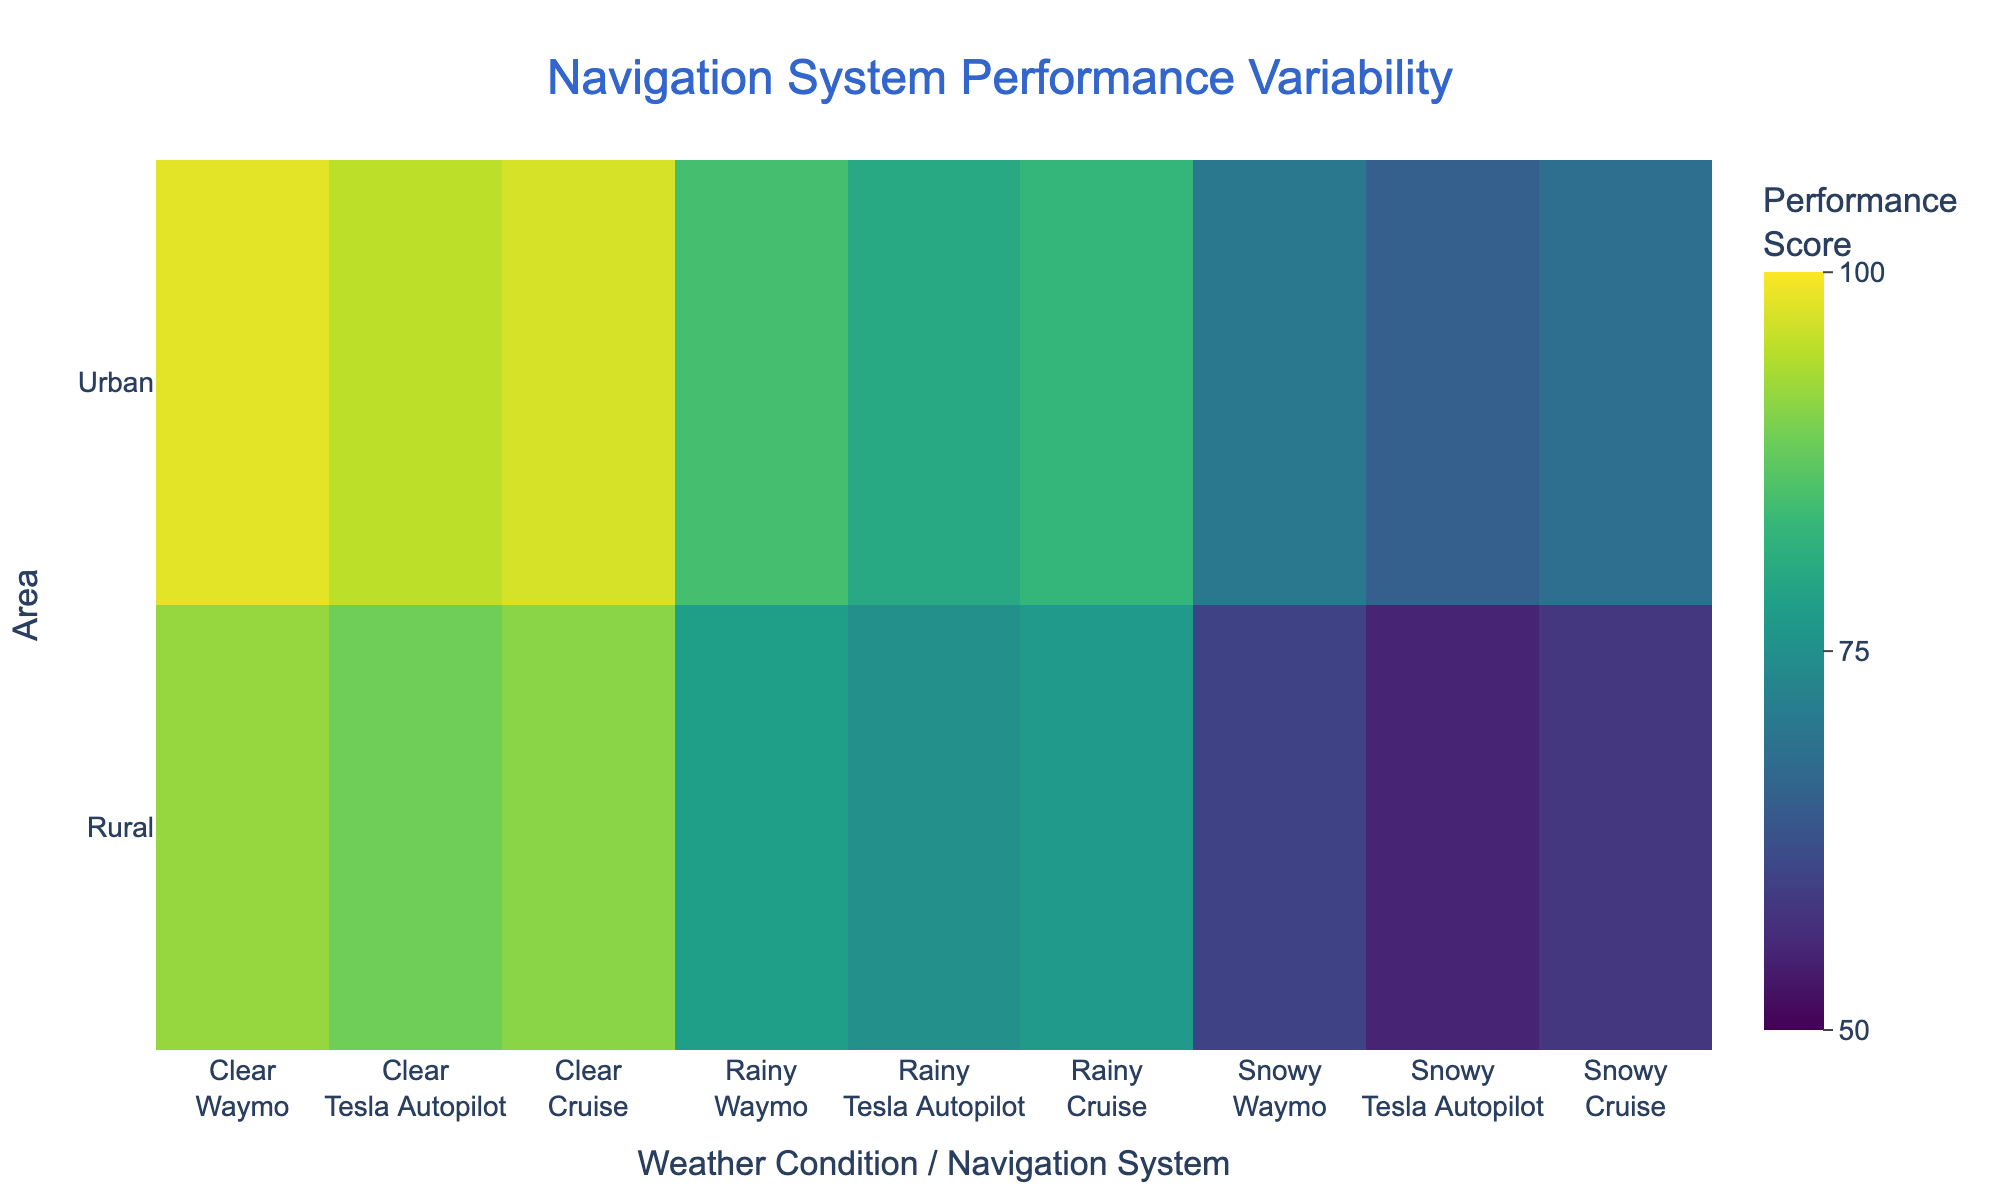What's the title of the figure? The title is located at the top of the figure, which reads "Navigation System Performance Variability."
Answer: Navigation System Performance Variability How does the performance score generally change with weather conditions from clear to snowy? By observing the color gradient from clearer (lighter) to snowy (darker), performance scores decrease as weather conditions change from clear to snowy.
Answer: Decreases What is the performance score of Waymo in urban areas under clear weather conditions? Look for the intersection of Urban area and Clear weather, and find Waymo. The score correlates with a specific color indicating a score of 98.
Answer: 98 Which navigation system shows the lowest performance in rural areas during rainy conditions? Within the rural area and rainy condition segment, Tesla Autopilot shows the lowest performance score which is evident from the corresponding color.
Answer: Tesla Autopilot Compare the performance of Waymo in urban areas with snowy weather conditions to its performance in rural areas with snowy weather conditions. Locate Waymo in both Urban and Rural sections for snowy weather: Urban has a performance of 70 and Rural has a performance of 60. Compare these values.
Answer: Urban: 70, Rural: 60 What is the average performance score for Tesla Autopilot across all weather conditions in rural areas? Find the scores for Tesla Autopilot under different weather conditions in rural areas (Clear: 89, Rainy: 75, Snowy: 55). Calculate the average: (89 + 75 + 55) / 3 = 219 / 3 = 73.
Answer: 73 Which navigation system has the highest performance score in rural areas during clear weather? For the rural area and clear weather condition, identify the highest score among Waymo, Tesla Autopilot, and Cruise. Waymo has the highest score (92).
Answer: Waymo By how many points does the performance of Cruise in urban areas under snowy weather conditions differ from that in rural areas under snowy weather conditions? Compare the scores: Urban (68), Rural (58). Calculate the difference: 68 - 58 = 10.
Answer: 10 Which weather condition causes the largest drop in performance score for Waymo when moving from urban to rural areas? Observe Waymo’s performance drop for each weather condition (Clear: 98 to 92, Rainy: 85 to 78, Snowy: 70 to 60). Snowy has the largest drop (10 points).
Answer: Snowy What is the overall trend in performance scores for navigation systems when comparing urban and rural areas? By reviewing the performance scores across all systems and conditions, urban areas consistently have higher performance scores compared to rural areas.
Answer: Higher in urban areas 